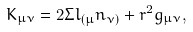Convert formula to latex. <formula><loc_0><loc_0><loc_500><loc_500>K _ { \mu \nu } = 2 \Sigma l _ { ( \mu } n _ { \nu ) } + r ^ { 2 } g _ { \mu \nu } ,</formula> 